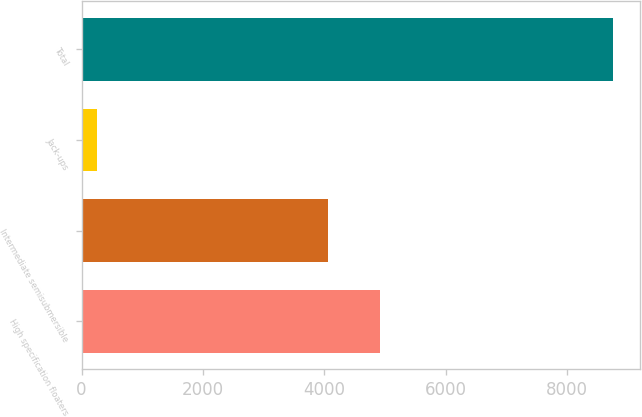Convert chart to OTSL. <chart><loc_0><loc_0><loc_500><loc_500><bar_chart><fcel>High specification floaters<fcel>Intermediate semisubmersible<fcel>Jack-ups<fcel>Total<nl><fcel>4912.1<fcel>4061<fcel>249<fcel>8760<nl></chart> 